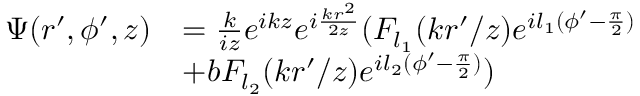Convert formula to latex. <formula><loc_0><loc_0><loc_500><loc_500>\begin{array} { r l } { \Psi ( r ^ { \prime } , \phi ^ { \prime } , z ) } & { = \frac { k } { i z } e ^ { i k z } e ^ { i \frac { k r ^ { 2 } } { 2 z } } ( F _ { l _ { 1 } } ( { k r ^ { \prime } } / { z } ) e ^ { i l _ { 1 } ( \phi ^ { \prime } - \frac { \pi } { 2 } ) } } \\ & { + b F _ { l _ { 2 } } ( { k r ^ { \prime } } / { z } ) e ^ { i l _ { 2 } ( \phi ^ { \prime } - \frac { \pi } { 2 } ) } ) } \end{array}</formula> 